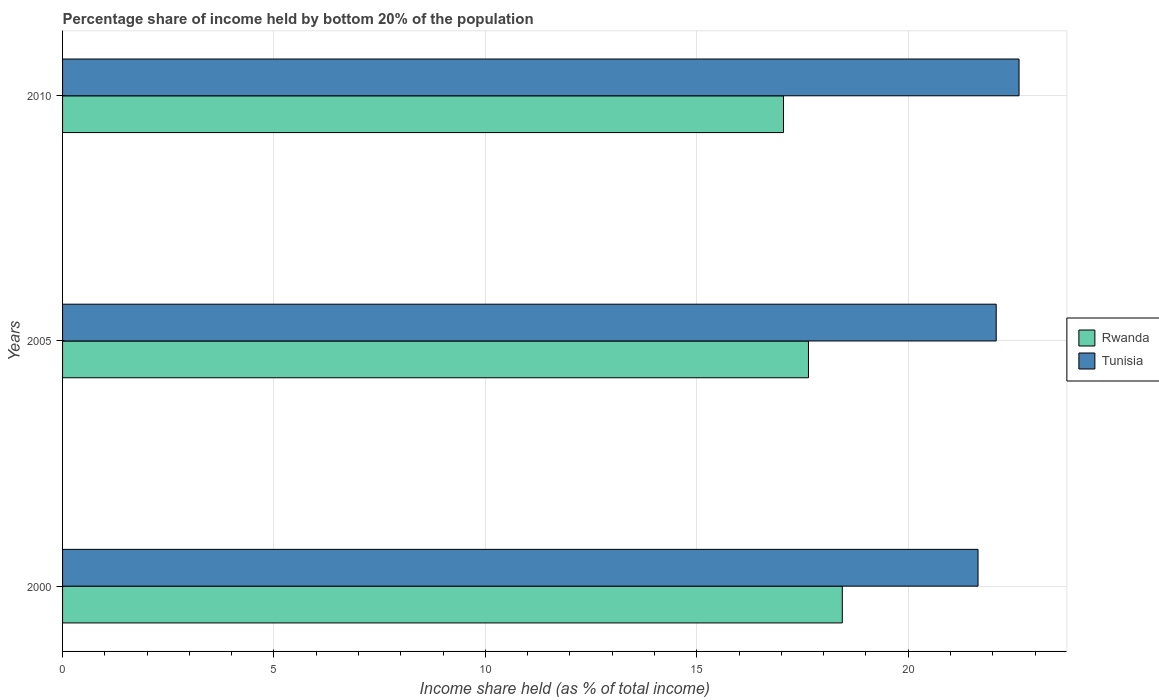How many different coloured bars are there?
Offer a terse response. 2. Are the number of bars on each tick of the Y-axis equal?
Your response must be concise. Yes. How many bars are there on the 3rd tick from the top?
Make the answer very short. 2. What is the label of the 1st group of bars from the top?
Give a very brief answer. 2010. In how many cases, is the number of bars for a given year not equal to the number of legend labels?
Ensure brevity in your answer.  0. What is the share of income held by bottom 20% of the population in Tunisia in 2010?
Provide a short and direct response. 22.62. Across all years, what is the maximum share of income held by bottom 20% of the population in Tunisia?
Ensure brevity in your answer.  22.62. Across all years, what is the minimum share of income held by bottom 20% of the population in Tunisia?
Ensure brevity in your answer.  21.65. In which year was the share of income held by bottom 20% of the population in Tunisia maximum?
Provide a succinct answer. 2010. What is the total share of income held by bottom 20% of the population in Tunisia in the graph?
Keep it short and to the point. 66.35. What is the difference between the share of income held by bottom 20% of the population in Tunisia in 2000 and that in 2005?
Offer a terse response. -0.43. What is the difference between the share of income held by bottom 20% of the population in Rwanda in 2005 and the share of income held by bottom 20% of the population in Tunisia in 2000?
Ensure brevity in your answer.  -4.01. What is the average share of income held by bottom 20% of the population in Rwanda per year?
Keep it short and to the point. 17.71. In the year 2010, what is the difference between the share of income held by bottom 20% of the population in Rwanda and share of income held by bottom 20% of the population in Tunisia?
Keep it short and to the point. -5.57. What is the ratio of the share of income held by bottom 20% of the population in Tunisia in 2005 to that in 2010?
Provide a short and direct response. 0.98. Is the share of income held by bottom 20% of the population in Rwanda in 2000 less than that in 2010?
Provide a short and direct response. No. Is the difference between the share of income held by bottom 20% of the population in Rwanda in 2000 and 2005 greater than the difference between the share of income held by bottom 20% of the population in Tunisia in 2000 and 2005?
Your answer should be very brief. Yes. What is the difference between the highest and the second highest share of income held by bottom 20% of the population in Tunisia?
Keep it short and to the point. 0.54. What is the difference between the highest and the lowest share of income held by bottom 20% of the population in Rwanda?
Keep it short and to the point. 1.39. In how many years, is the share of income held by bottom 20% of the population in Tunisia greater than the average share of income held by bottom 20% of the population in Tunisia taken over all years?
Keep it short and to the point. 1. What does the 2nd bar from the top in 2005 represents?
Provide a succinct answer. Rwanda. What does the 1st bar from the bottom in 2005 represents?
Offer a terse response. Rwanda. How many years are there in the graph?
Keep it short and to the point. 3. Does the graph contain grids?
Offer a terse response. Yes. Where does the legend appear in the graph?
Your answer should be compact. Center right. How are the legend labels stacked?
Keep it short and to the point. Vertical. What is the title of the graph?
Keep it short and to the point. Percentage share of income held by bottom 20% of the population. What is the label or title of the X-axis?
Your answer should be compact. Income share held (as % of total income). What is the Income share held (as % of total income) in Rwanda in 2000?
Give a very brief answer. 18.44. What is the Income share held (as % of total income) in Tunisia in 2000?
Your answer should be very brief. 21.65. What is the Income share held (as % of total income) in Rwanda in 2005?
Ensure brevity in your answer.  17.64. What is the Income share held (as % of total income) in Tunisia in 2005?
Your answer should be compact. 22.08. What is the Income share held (as % of total income) in Rwanda in 2010?
Your answer should be compact. 17.05. What is the Income share held (as % of total income) of Tunisia in 2010?
Keep it short and to the point. 22.62. Across all years, what is the maximum Income share held (as % of total income) in Rwanda?
Offer a terse response. 18.44. Across all years, what is the maximum Income share held (as % of total income) in Tunisia?
Your answer should be very brief. 22.62. Across all years, what is the minimum Income share held (as % of total income) in Rwanda?
Offer a terse response. 17.05. Across all years, what is the minimum Income share held (as % of total income) of Tunisia?
Ensure brevity in your answer.  21.65. What is the total Income share held (as % of total income) in Rwanda in the graph?
Make the answer very short. 53.13. What is the total Income share held (as % of total income) in Tunisia in the graph?
Make the answer very short. 66.35. What is the difference between the Income share held (as % of total income) in Rwanda in 2000 and that in 2005?
Offer a terse response. 0.8. What is the difference between the Income share held (as % of total income) of Tunisia in 2000 and that in 2005?
Ensure brevity in your answer.  -0.43. What is the difference between the Income share held (as % of total income) in Rwanda in 2000 and that in 2010?
Keep it short and to the point. 1.39. What is the difference between the Income share held (as % of total income) in Tunisia in 2000 and that in 2010?
Offer a terse response. -0.97. What is the difference between the Income share held (as % of total income) in Rwanda in 2005 and that in 2010?
Your response must be concise. 0.59. What is the difference between the Income share held (as % of total income) of Tunisia in 2005 and that in 2010?
Keep it short and to the point. -0.54. What is the difference between the Income share held (as % of total income) in Rwanda in 2000 and the Income share held (as % of total income) in Tunisia in 2005?
Give a very brief answer. -3.64. What is the difference between the Income share held (as % of total income) of Rwanda in 2000 and the Income share held (as % of total income) of Tunisia in 2010?
Keep it short and to the point. -4.18. What is the difference between the Income share held (as % of total income) in Rwanda in 2005 and the Income share held (as % of total income) in Tunisia in 2010?
Offer a very short reply. -4.98. What is the average Income share held (as % of total income) in Rwanda per year?
Provide a succinct answer. 17.71. What is the average Income share held (as % of total income) of Tunisia per year?
Ensure brevity in your answer.  22.12. In the year 2000, what is the difference between the Income share held (as % of total income) in Rwanda and Income share held (as % of total income) in Tunisia?
Your answer should be compact. -3.21. In the year 2005, what is the difference between the Income share held (as % of total income) in Rwanda and Income share held (as % of total income) in Tunisia?
Offer a very short reply. -4.44. In the year 2010, what is the difference between the Income share held (as % of total income) of Rwanda and Income share held (as % of total income) of Tunisia?
Provide a succinct answer. -5.57. What is the ratio of the Income share held (as % of total income) in Rwanda in 2000 to that in 2005?
Ensure brevity in your answer.  1.05. What is the ratio of the Income share held (as % of total income) in Tunisia in 2000 to that in 2005?
Provide a short and direct response. 0.98. What is the ratio of the Income share held (as % of total income) of Rwanda in 2000 to that in 2010?
Your answer should be very brief. 1.08. What is the ratio of the Income share held (as % of total income) of Tunisia in 2000 to that in 2010?
Give a very brief answer. 0.96. What is the ratio of the Income share held (as % of total income) in Rwanda in 2005 to that in 2010?
Your response must be concise. 1.03. What is the ratio of the Income share held (as % of total income) of Tunisia in 2005 to that in 2010?
Give a very brief answer. 0.98. What is the difference between the highest and the second highest Income share held (as % of total income) of Rwanda?
Ensure brevity in your answer.  0.8. What is the difference between the highest and the second highest Income share held (as % of total income) in Tunisia?
Your answer should be compact. 0.54. What is the difference between the highest and the lowest Income share held (as % of total income) of Rwanda?
Ensure brevity in your answer.  1.39. 